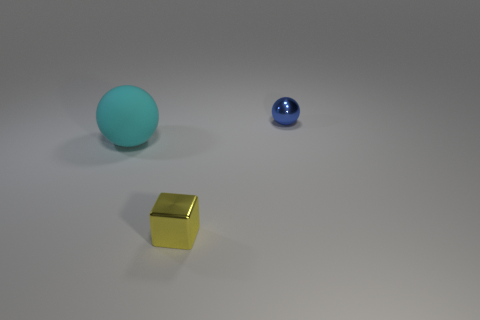What is the size of the thing that is behind the large cyan rubber object?
Make the answer very short. Small. What number of cyan objects are on the left side of the shiny thing left of the tiny blue metallic ball?
Give a very brief answer. 1. Is the shape of the small thing that is behind the big cyan rubber ball the same as the big cyan thing in front of the tiny ball?
Give a very brief answer. Yes. How many things are both behind the tiny yellow cube and to the right of the big cyan rubber thing?
Your response must be concise. 1. What shape is the yellow object that is the same size as the shiny ball?
Your answer should be very brief. Cube. There is a yellow shiny cube; are there any cyan rubber objects behind it?
Your answer should be compact. Yes. Do the sphere on the left side of the small yellow block and the small thing in front of the small blue thing have the same material?
Provide a short and direct response. No. How many things are the same size as the yellow cube?
Offer a terse response. 1. What is the material of the sphere in front of the blue object?
Provide a short and direct response. Rubber. How many tiny blue things are the same shape as the big rubber object?
Provide a succinct answer. 1. 